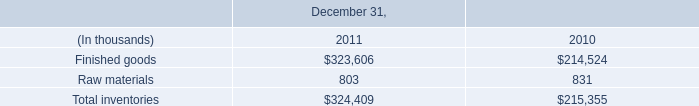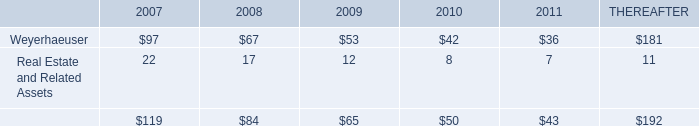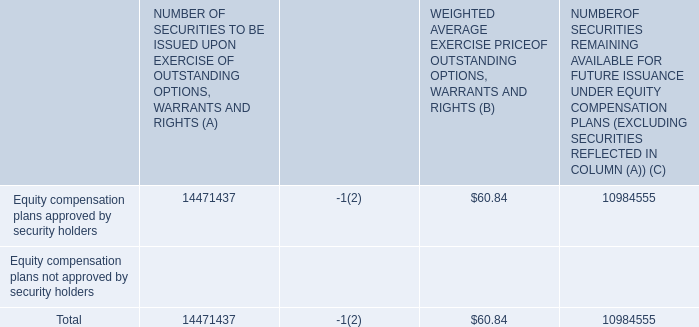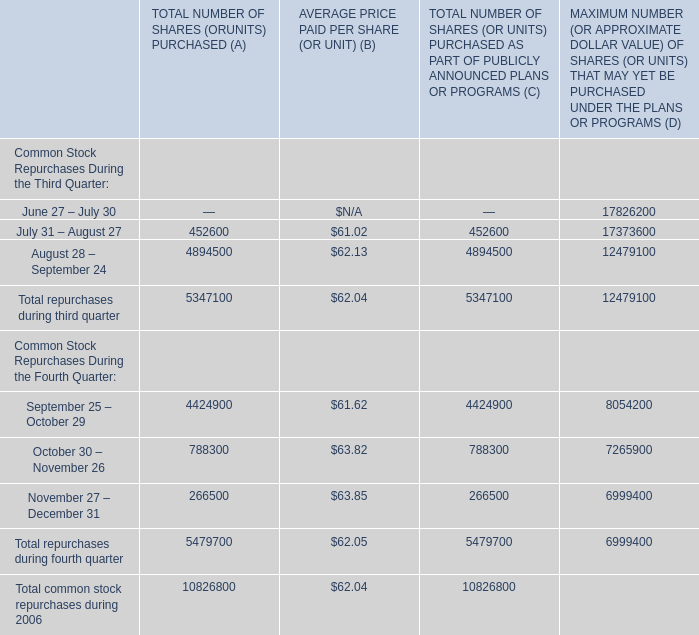What is the 50% of the value of the WEIGHTED AVERAGE EXERCISE PRICE OF OUTSTANDING OPTIONS, WARRANTS AND RIGHTS (B) for Total? 
Computations: (0.5 * 60.84)
Answer: 30.42. 